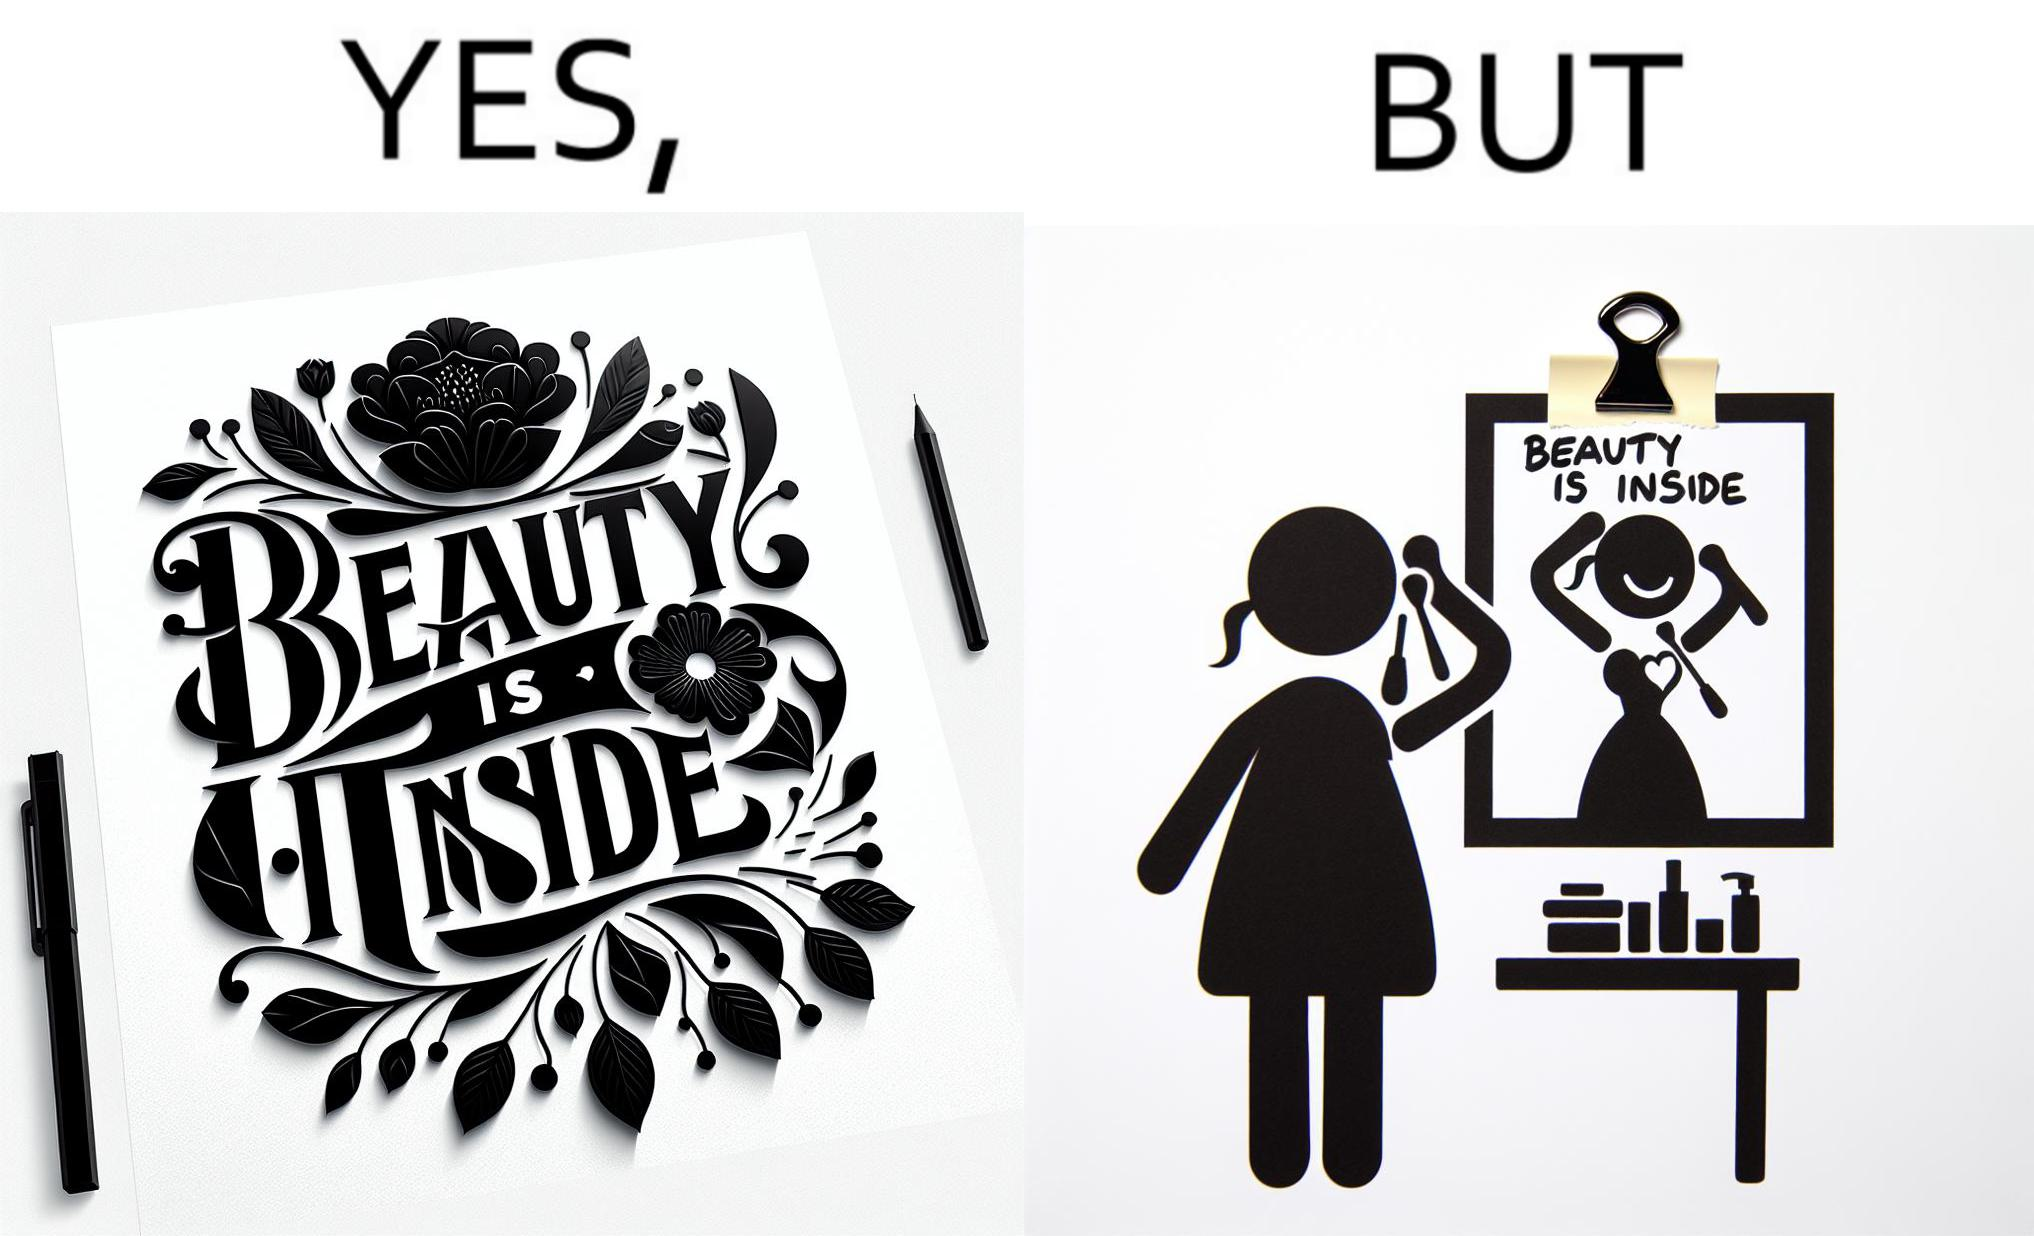Why is this image considered satirical? The image is satirical because while the text on the paper says that beauty lies inside, the woman ignores the note and continues to apply makeup to improve her outer beauty. 